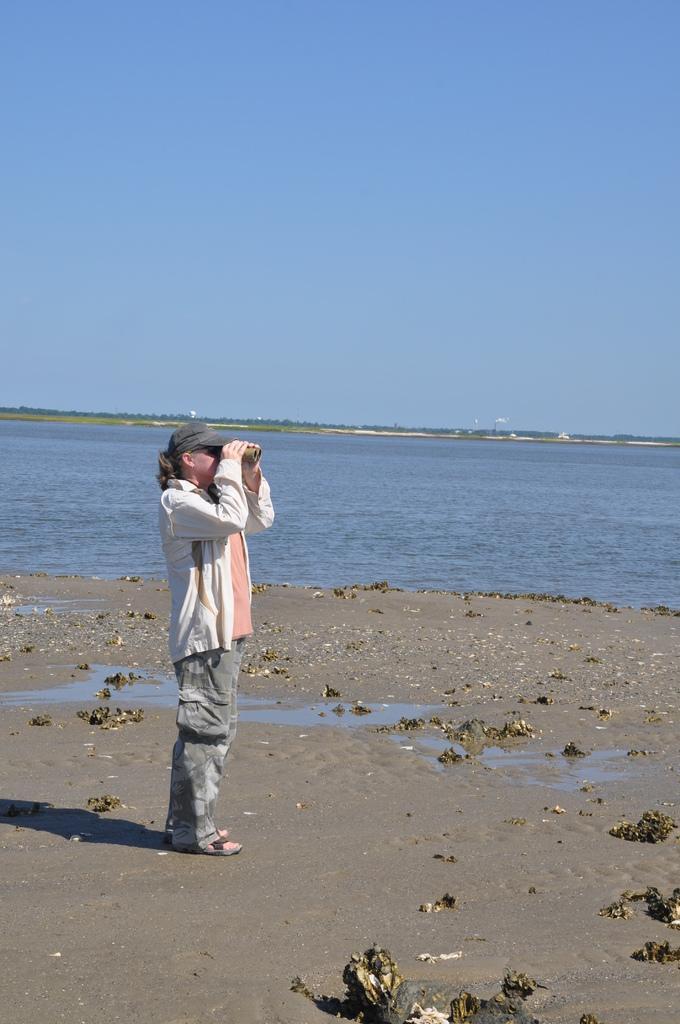Please provide a concise description of this image. In this image, I can see a person standing and holding a binoculars. Here is the water flowing. This is the sky. This person wore a cap, jerkin, trouser and sandals. 